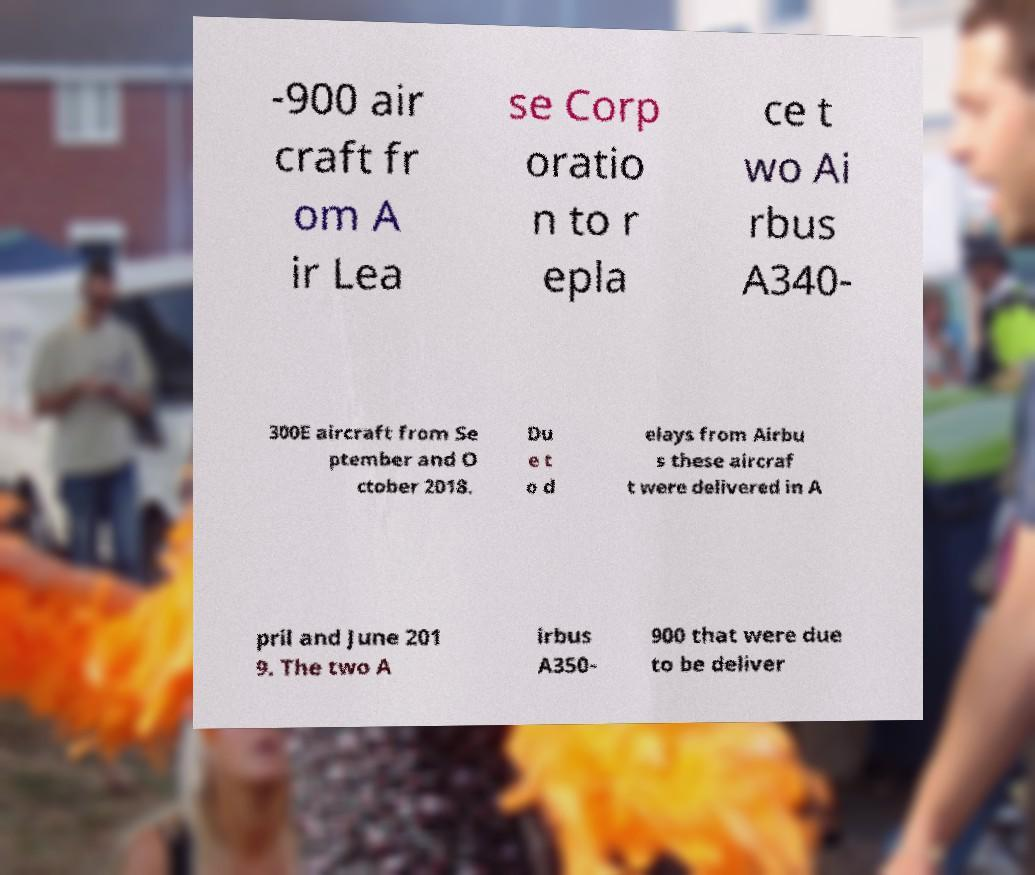I need the written content from this picture converted into text. Can you do that? -900 air craft fr om A ir Lea se Corp oratio n to r epla ce t wo Ai rbus A340- 300E aircraft from Se ptember and O ctober 2018. Du e t o d elays from Airbu s these aircraf t were delivered in A pril and June 201 9. The two A irbus A350- 900 that were due to be deliver 